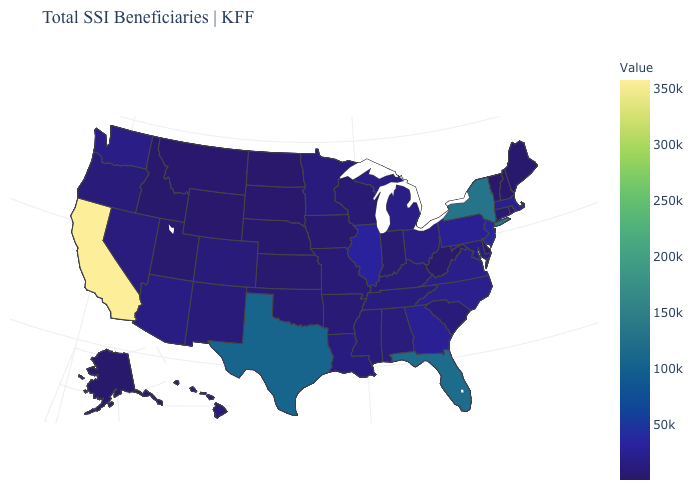Which states hav the highest value in the South?
Keep it brief. Florida. Does the map have missing data?
Quick response, please. No. Among the states that border West Virginia , which have the highest value?
Be succinct. Pennsylvania. Is the legend a continuous bar?
Short answer required. Yes. 